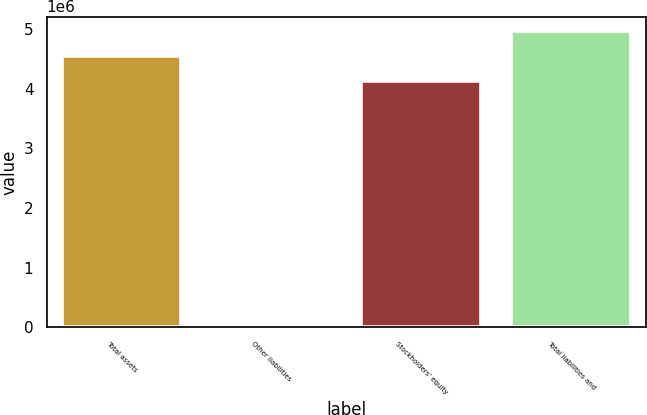Convert chart to OTSL. <chart><loc_0><loc_0><loc_500><loc_500><bar_chart><fcel>Total assets<fcel>Other liabilities<fcel>Stockholders' equity<fcel>Total liabilities and<nl><fcel>4.54454e+06<fcel>51<fcel>4.13134e+06<fcel>4.95773e+06<nl></chart> 